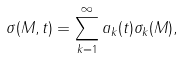Convert formula to latex. <formula><loc_0><loc_0><loc_500><loc_500>\sigma ( M , t ) = \sum _ { k = 1 } ^ { \infty } a _ { k } ( t ) \sigma _ { k } ( M ) ,</formula> 